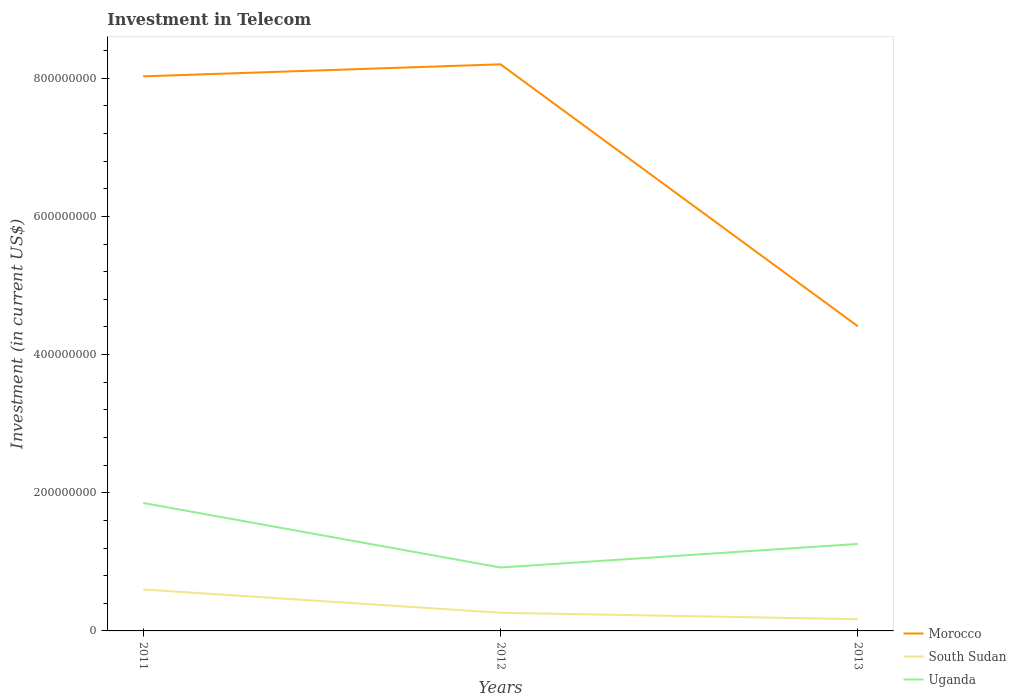How many different coloured lines are there?
Ensure brevity in your answer.  3. Across all years, what is the maximum amount invested in telecom in Uganda?
Your answer should be very brief. 9.18e+07. What is the total amount invested in telecom in Morocco in the graph?
Offer a very short reply. -1.74e+07. What is the difference between the highest and the second highest amount invested in telecom in Uganda?
Your answer should be very brief. 9.34e+07. What is the difference between the highest and the lowest amount invested in telecom in Morocco?
Make the answer very short. 2. Is the amount invested in telecom in Morocco strictly greater than the amount invested in telecom in South Sudan over the years?
Your answer should be very brief. No. How many years are there in the graph?
Provide a short and direct response. 3. Does the graph contain any zero values?
Your answer should be compact. No. Where does the legend appear in the graph?
Offer a very short reply. Bottom right. How are the legend labels stacked?
Give a very brief answer. Vertical. What is the title of the graph?
Give a very brief answer. Investment in Telecom. What is the label or title of the Y-axis?
Your answer should be compact. Investment (in current US$). What is the Investment (in current US$) in Morocco in 2011?
Your answer should be very brief. 8.03e+08. What is the Investment (in current US$) in South Sudan in 2011?
Provide a succinct answer. 6.00e+07. What is the Investment (in current US$) of Uganda in 2011?
Ensure brevity in your answer.  1.85e+08. What is the Investment (in current US$) in Morocco in 2012?
Provide a short and direct response. 8.20e+08. What is the Investment (in current US$) in South Sudan in 2012?
Offer a very short reply. 2.63e+07. What is the Investment (in current US$) of Uganda in 2012?
Offer a terse response. 9.18e+07. What is the Investment (in current US$) in Morocco in 2013?
Make the answer very short. 4.41e+08. What is the Investment (in current US$) in South Sudan in 2013?
Provide a succinct answer. 1.70e+07. What is the Investment (in current US$) in Uganda in 2013?
Your answer should be very brief. 1.26e+08. Across all years, what is the maximum Investment (in current US$) in Morocco?
Your answer should be compact. 8.20e+08. Across all years, what is the maximum Investment (in current US$) in South Sudan?
Ensure brevity in your answer.  6.00e+07. Across all years, what is the maximum Investment (in current US$) of Uganda?
Your answer should be compact. 1.85e+08. Across all years, what is the minimum Investment (in current US$) in Morocco?
Offer a terse response. 4.41e+08. Across all years, what is the minimum Investment (in current US$) of South Sudan?
Provide a succinct answer. 1.70e+07. Across all years, what is the minimum Investment (in current US$) in Uganda?
Your answer should be compact. 9.18e+07. What is the total Investment (in current US$) in Morocco in the graph?
Ensure brevity in your answer.  2.06e+09. What is the total Investment (in current US$) in South Sudan in the graph?
Make the answer very short. 1.03e+08. What is the total Investment (in current US$) in Uganda in the graph?
Your response must be concise. 4.03e+08. What is the difference between the Investment (in current US$) of Morocco in 2011 and that in 2012?
Keep it short and to the point. -1.74e+07. What is the difference between the Investment (in current US$) of South Sudan in 2011 and that in 2012?
Give a very brief answer. 3.37e+07. What is the difference between the Investment (in current US$) in Uganda in 2011 and that in 2012?
Provide a succinct answer. 9.34e+07. What is the difference between the Investment (in current US$) in Morocco in 2011 and that in 2013?
Offer a very short reply. 3.62e+08. What is the difference between the Investment (in current US$) in South Sudan in 2011 and that in 2013?
Your answer should be very brief. 4.30e+07. What is the difference between the Investment (in current US$) in Uganda in 2011 and that in 2013?
Make the answer very short. 5.93e+07. What is the difference between the Investment (in current US$) in Morocco in 2012 and that in 2013?
Offer a terse response. 3.79e+08. What is the difference between the Investment (in current US$) in South Sudan in 2012 and that in 2013?
Ensure brevity in your answer.  9.30e+06. What is the difference between the Investment (in current US$) of Uganda in 2012 and that in 2013?
Make the answer very short. -3.41e+07. What is the difference between the Investment (in current US$) of Morocco in 2011 and the Investment (in current US$) of South Sudan in 2012?
Your response must be concise. 7.76e+08. What is the difference between the Investment (in current US$) of Morocco in 2011 and the Investment (in current US$) of Uganda in 2012?
Keep it short and to the point. 7.11e+08. What is the difference between the Investment (in current US$) of South Sudan in 2011 and the Investment (in current US$) of Uganda in 2012?
Provide a short and direct response. -3.18e+07. What is the difference between the Investment (in current US$) of Morocco in 2011 and the Investment (in current US$) of South Sudan in 2013?
Make the answer very short. 7.86e+08. What is the difference between the Investment (in current US$) in Morocco in 2011 and the Investment (in current US$) in Uganda in 2013?
Provide a short and direct response. 6.77e+08. What is the difference between the Investment (in current US$) in South Sudan in 2011 and the Investment (in current US$) in Uganda in 2013?
Your answer should be very brief. -6.59e+07. What is the difference between the Investment (in current US$) in Morocco in 2012 and the Investment (in current US$) in South Sudan in 2013?
Make the answer very short. 8.03e+08. What is the difference between the Investment (in current US$) in Morocco in 2012 and the Investment (in current US$) in Uganda in 2013?
Offer a terse response. 6.94e+08. What is the difference between the Investment (in current US$) of South Sudan in 2012 and the Investment (in current US$) of Uganda in 2013?
Keep it short and to the point. -9.96e+07. What is the average Investment (in current US$) of Morocco per year?
Offer a very short reply. 6.88e+08. What is the average Investment (in current US$) of South Sudan per year?
Keep it short and to the point. 3.44e+07. What is the average Investment (in current US$) in Uganda per year?
Provide a succinct answer. 1.34e+08. In the year 2011, what is the difference between the Investment (in current US$) of Morocco and Investment (in current US$) of South Sudan?
Provide a short and direct response. 7.43e+08. In the year 2011, what is the difference between the Investment (in current US$) in Morocco and Investment (in current US$) in Uganda?
Give a very brief answer. 6.18e+08. In the year 2011, what is the difference between the Investment (in current US$) in South Sudan and Investment (in current US$) in Uganda?
Your answer should be compact. -1.25e+08. In the year 2012, what is the difference between the Investment (in current US$) in Morocco and Investment (in current US$) in South Sudan?
Make the answer very short. 7.94e+08. In the year 2012, what is the difference between the Investment (in current US$) in Morocco and Investment (in current US$) in Uganda?
Provide a short and direct response. 7.28e+08. In the year 2012, what is the difference between the Investment (in current US$) in South Sudan and Investment (in current US$) in Uganda?
Give a very brief answer. -6.55e+07. In the year 2013, what is the difference between the Investment (in current US$) in Morocco and Investment (in current US$) in South Sudan?
Your answer should be compact. 4.24e+08. In the year 2013, what is the difference between the Investment (in current US$) of Morocco and Investment (in current US$) of Uganda?
Make the answer very short. 3.15e+08. In the year 2013, what is the difference between the Investment (in current US$) of South Sudan and Investment (in current US$) of Uganda?
Make the answer very short. -1.09e+08. What is the ratio of the Investment (in current US$) in Morocco in 2011 to that in 2012?
Ensure brevity in your answer.  0.98. What is the ratio of the Investment (in current US$) of South Sudan in 2011 to that in 2012?
Keep it short and to the point. 2.28. What is the ratio of the Investment (in current US$) of Uganda in 2011 to that in 2012?
Ensure brevity in your answer.  2.02. What is the ratio of the Investment (in current US$) of Morocco in 2011 to that in 2013?
Provide a short and direct response. 1.82. What is the ratio of the Investment (in current US$) in South Sudan in 2011 to that in 2013?
Your answer should be compact. 3.53. What is the ratio of the Investment (in current US$) in Uganda in 2011 to that in 2013?
Your answer should be very brief. 1.47. What is the ratio of the Investment (in current US$) of Morocco in 2012 to that in 2013?
Offer a very short reply. 1.86. What is the ratio of the Investment (in current US$) of South Sudan in 2012 to that in 2013?
Your answer should be very brief. 1.55. What is the ratio of the Investment (in current US$) in Uganda in 2012 to that in 2013?
Keep it short and to the point. 0.73. What is the difference between the highest and the second highest Investment (in current US$) in Morocco?
Make the answer very short. 1.74e+07. What is the difference between the highest and the second highest Investment (in current US$) in South Sudan?
Your answer should be compact. 3.37e+07. What is the difference between the highest and the second highest Investment (in current US$) of Uganda?
Give a very brief answer. 5.93e+07. What is the difference between the highest and the lowest Investment (in current US$) in Morocco?
Offer a terse response. 3.79e+08. What is the difference between the highest and the lowest Investment (in current US$) of South Sudan?
Your answer should be very brief. 4.30e+07. What is the difference between the highest and the lowest Investment (in current US$) in Uganda?
Provide a short and direct response. 9.34e+07. 